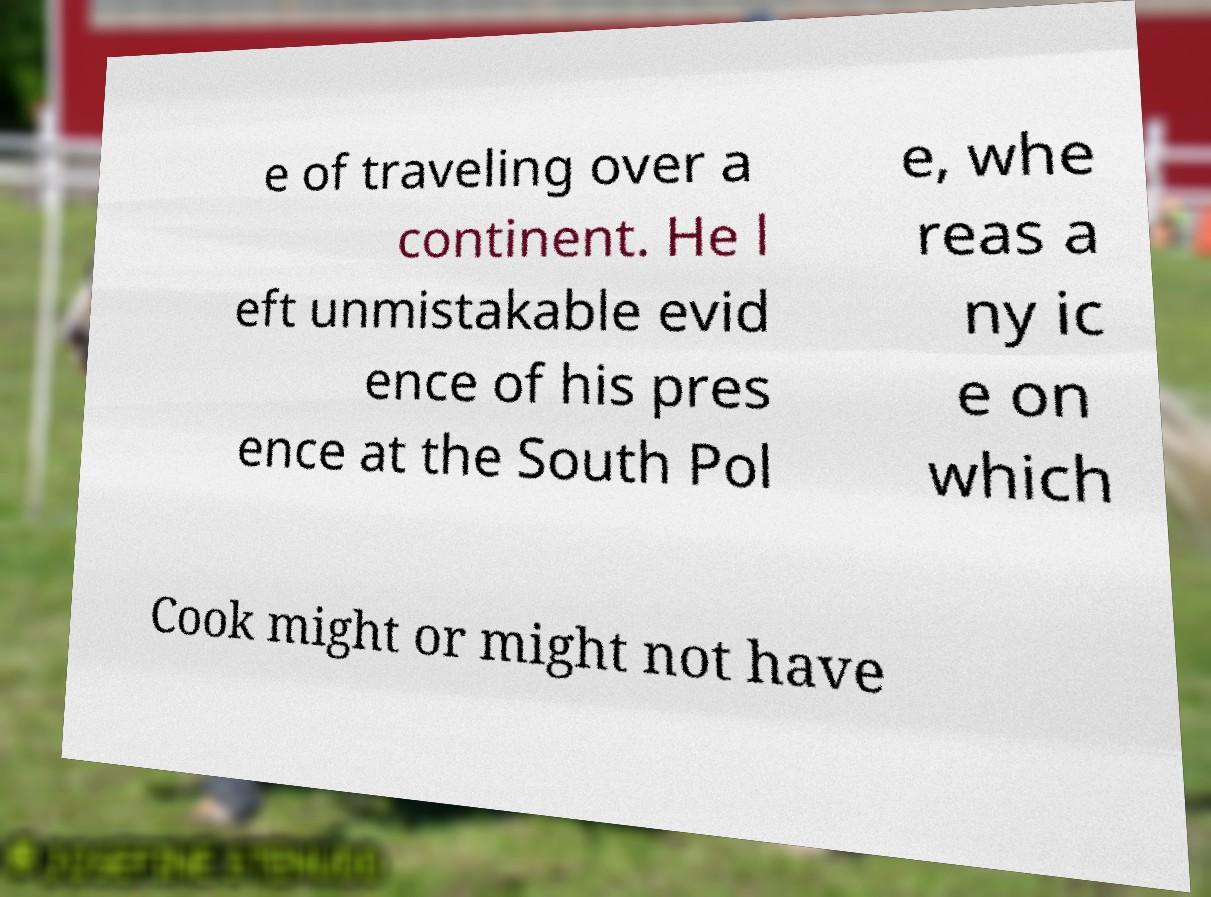Could you assist in decoding the text presented in this image and type it out clearly? e of traveling over a continent. He l eft unmistakable evid ence of his pres ence at the South Pol e, whe reas a ny ic e on which Cook might or might not have 